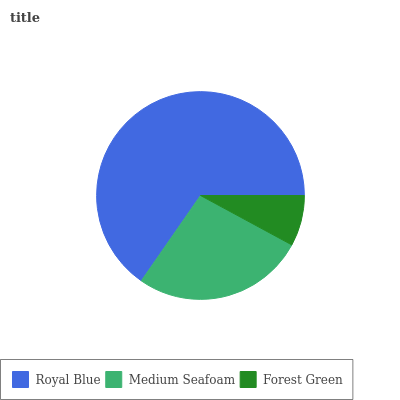Is Forest Green the minimum?
Answer yes or no. Yes. Is Royal Blue the maximum?
Answer yes or no. Yes. Is Medium Seafoam the minimum?
Answer yes or no. No. Is Medium Seafoam the maximum?
Answer yes or no. No. Is Royal Blue greater than Medium Seafoam?
Answer yes or no. Yes. Is Medium Seafoam less than Royal Blue?
Answer yes or no. Yes. Is Medium Seafoam greater than Royal Blue?
Answer yes or no. No. Is Royal Blue less than Medium Seafoam?
Answer yes or no. No. Is Medium Seafoam the high median?
Answer yes or no. Yes. Is Medium Seafoam the low median?
Answer yes or no. Yes. Is Royal Blue the high median?
Answer yes or no. No. Is Royal Blue the low median?
Answer yes or no. No. 